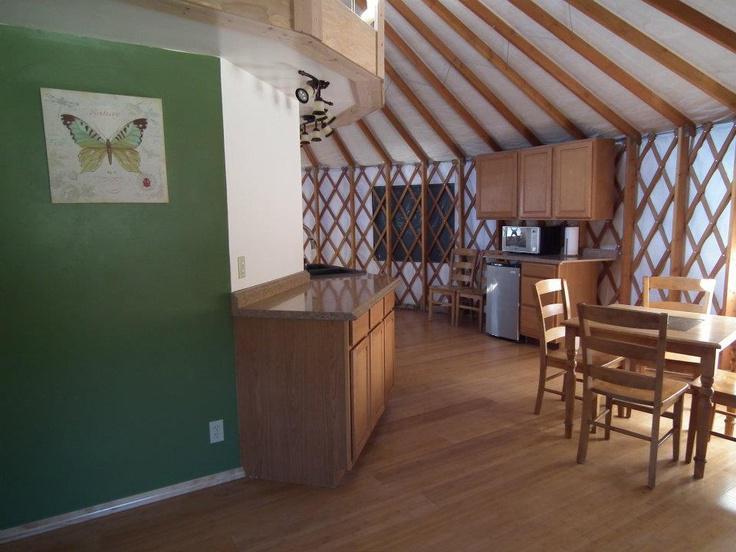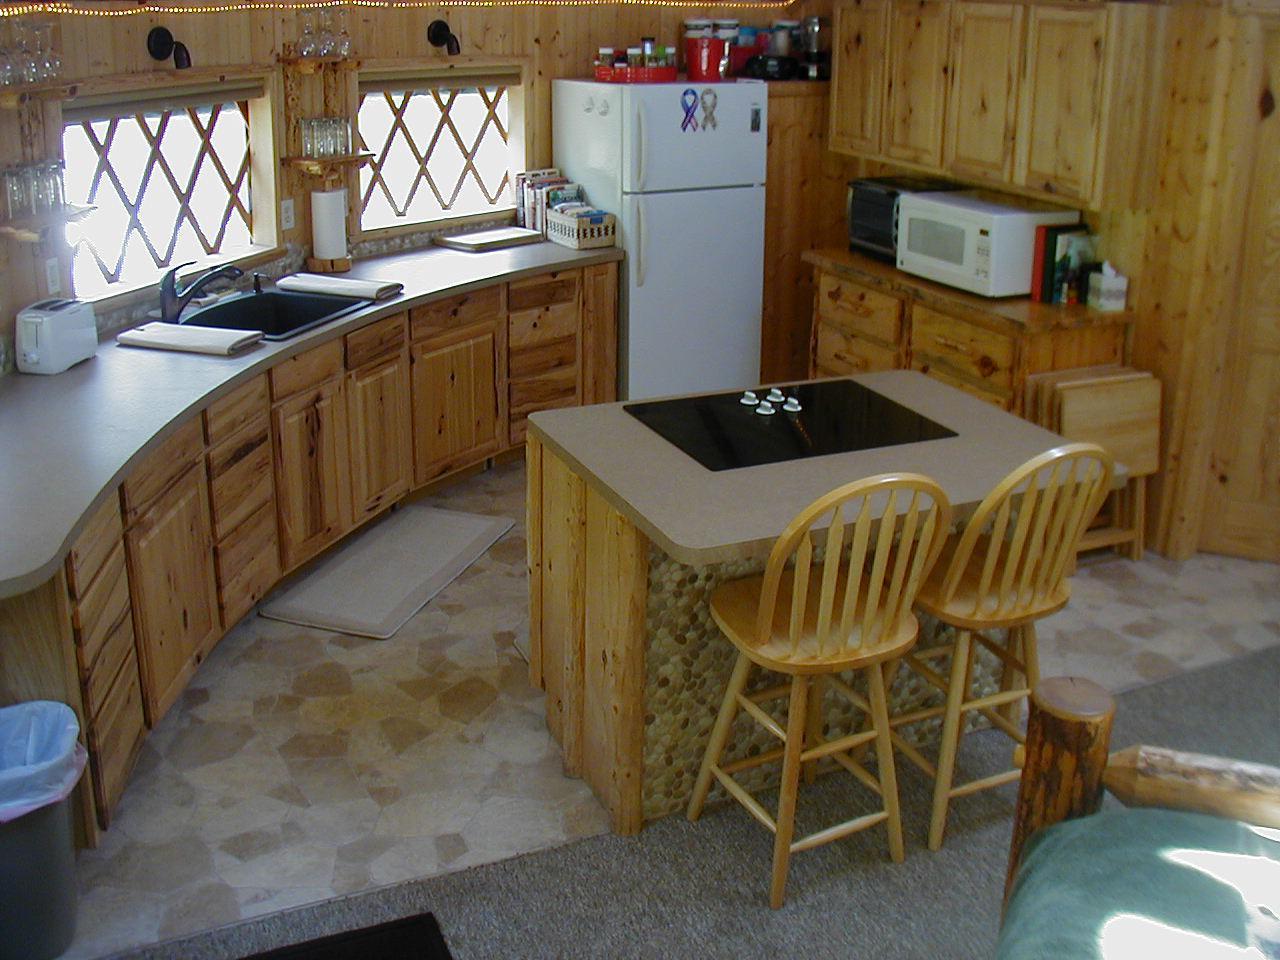The first image is the image on the left, the second image is the image on the right. Evaluate the accuracy of this statement regarding the images: "A ladder with rungs leads up to a loft area in at least one image.". Is it true? Answer yes or no. No. The first image is the image on the left, the second image is the image on the right. Assess this claim about the two images: "A ladder goes up to an upper area of the hut in one of the images.". Correct or not? Answer yes or no. No. 